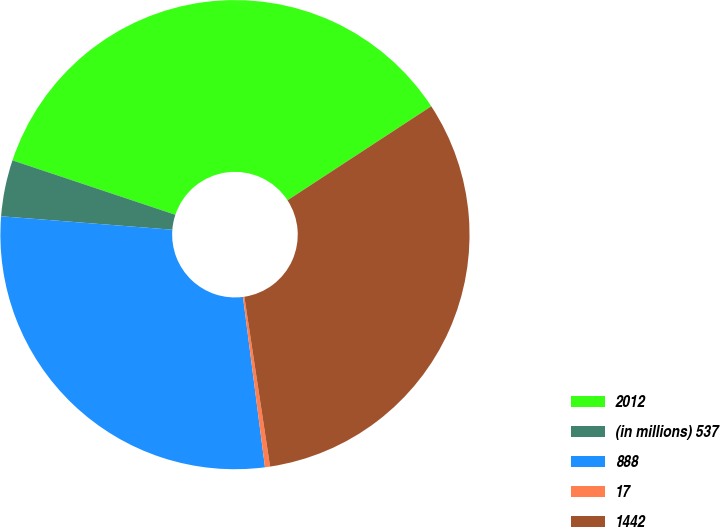Convert chart to OTSL. <chart><loc_0><loc_0><loc_500><loc_500><pie_chart><fcel>2012<fcel>(in millions) 537<fcel>888<fcel>17<fcel>1442<nl><fcel>35.65%<fcel>3.88%<fcel>28.29%<fcel>0.35%<fcel>31.82%<nl></chart> 